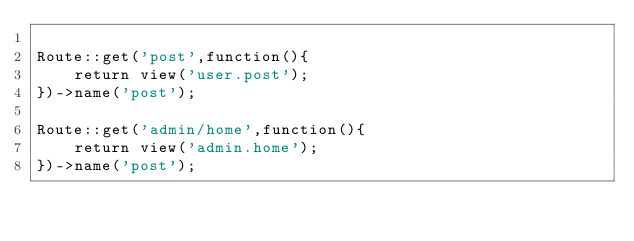<code> <loc_0><loc_0><loc_500><loc_500><_PHP_>
Route::get('post',function(){
	return view('user.post');
})->name('post');

Route::get('admin/home',function(){
	return view('admin.home');
})->name('post');</code> 